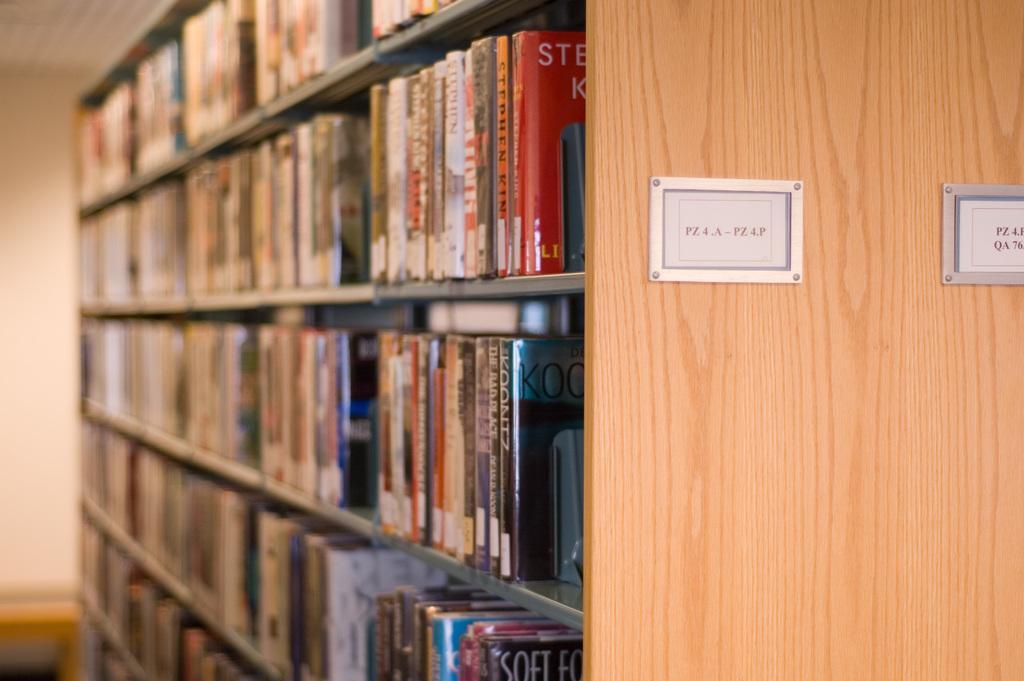Describe this image in one or two sentences. In this image there are many books placed in a rack. There are also two text boards attached to the wooden rack. 